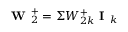Convert formula to latex. <formula><loc_0><loc_0><loc_500><loc_500>W _ { 2 } ^ { + } = \Sigma W _ { 2 k } ^ { + } I _ { k }</formula> 